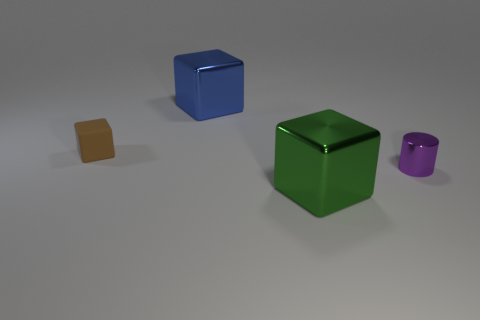Is there anything else that has the same material as the small cube?
Your answer should be very brief. No. Is there anything else that has the same color as the metallic cylinder?
Your response must be concise. No. The large block on the left side of the large object in front of the tiny purple object is what color?
Offer a very short reply. Blue. What is the big block in front of the metal block that is behind the brown block that is to the left of the big blue shiny cube made of?
Provide a short and direct response. Metal. How many other blue shiny blocks have the same size as the blue shiny cube?
Your response must be concise. 0. What material is the block that is in front of the large blue block and behind the green cube?
Provide a short and direct response. Rubber. How many blue objects are behind the blue thing?
Provide a short and direct response. 0. There is a large green metal object; is it the same shape as the tiny brown thing that is behind the green cube?
Offer a very short reply. Yes. Is there a blue thing of the same shape as the green object?
Your response must be concise. Yes. What shape is the small object that is on the right side of the large metal object that is behind the large green thing?
Offer a terse response. Cylinder. 